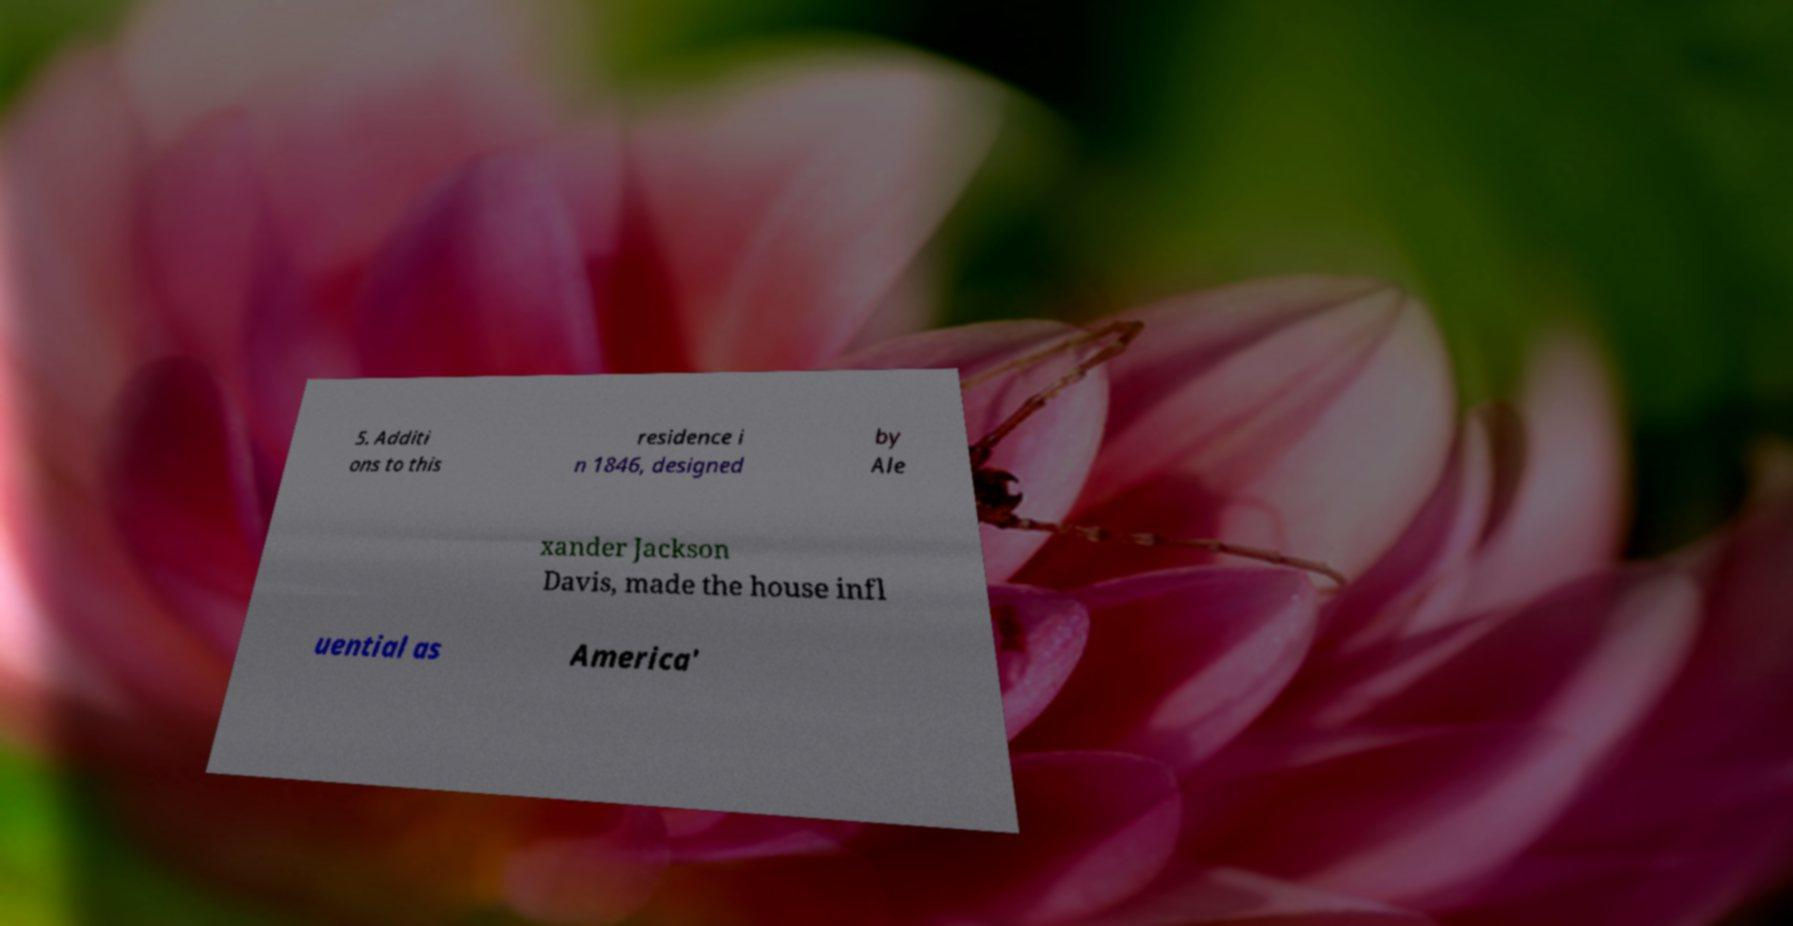I need the written content from this picture converted into text. Can you do that? 5. Additi ons to this residence i n 1846, designed by Ale xander Jackson Davis, made the house infl uential as America' 